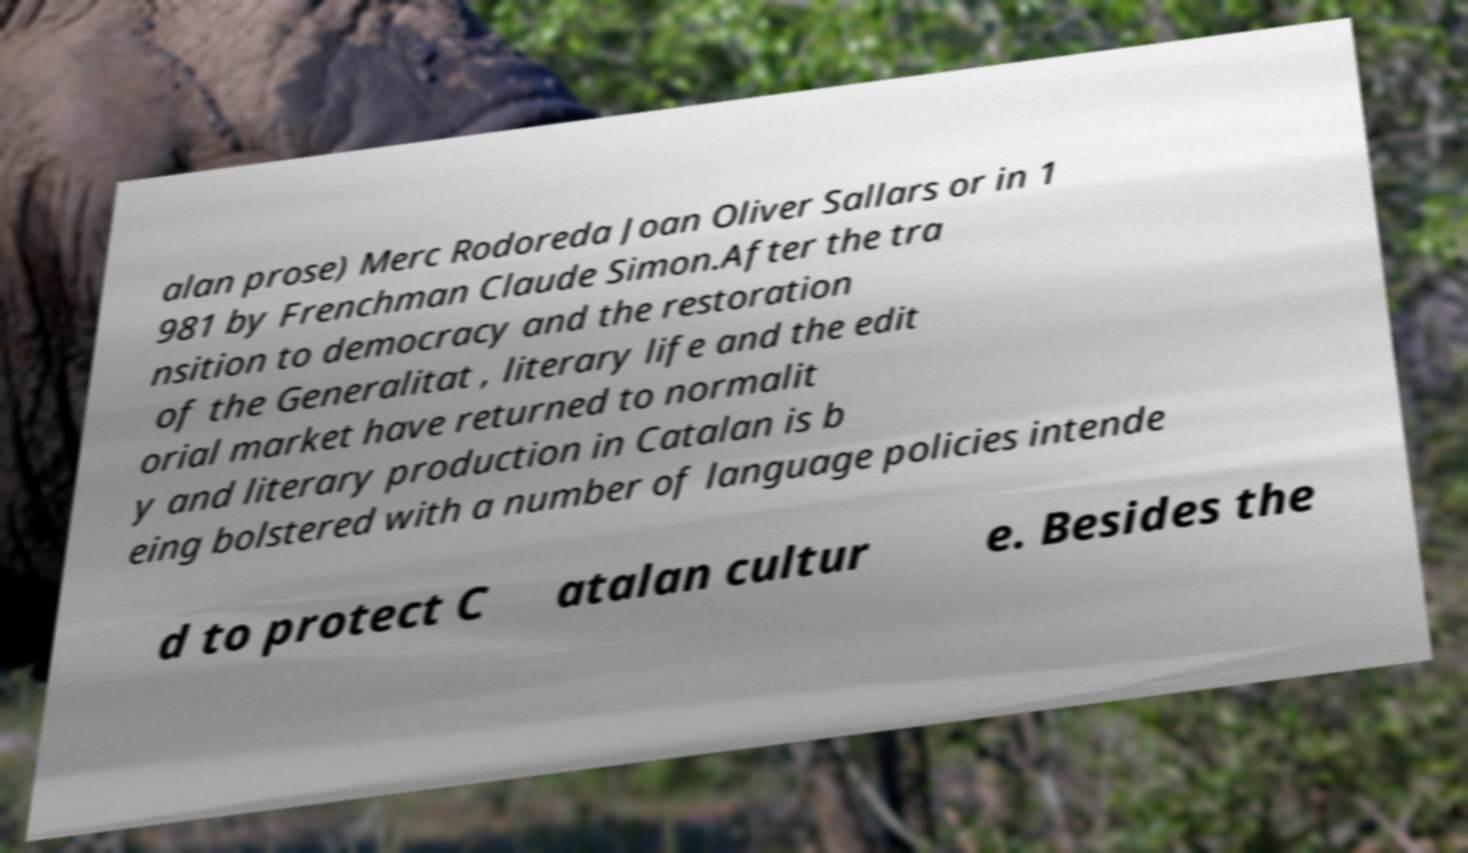For documentation purposes, I need the text within this image transcribed. Could you provide that? alan prose) Merc Rodoreda Joan Oliver Sallars or in 1 981 by Frenchman Claude Simon.After the tra nsition to democracy and the restoration of the Generalitat , literary life and the edit orial market have returned to normalit y and literary production in Catalan is b eing bolstered with a number of language policies intende d to protect C atalan cultur e. Besides the 